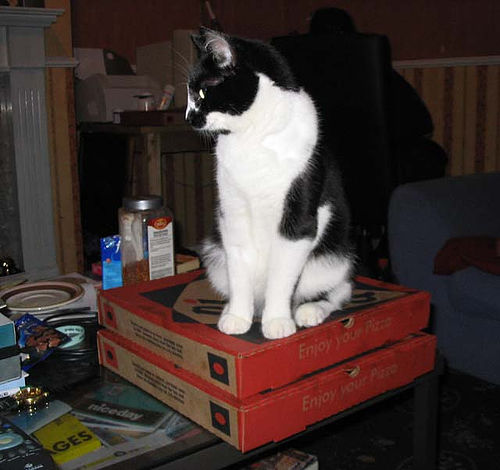Please transcribe the text in this image. AGES niceday ENJOY YOUR PIZZA PIZZA YOUR Enjoy 